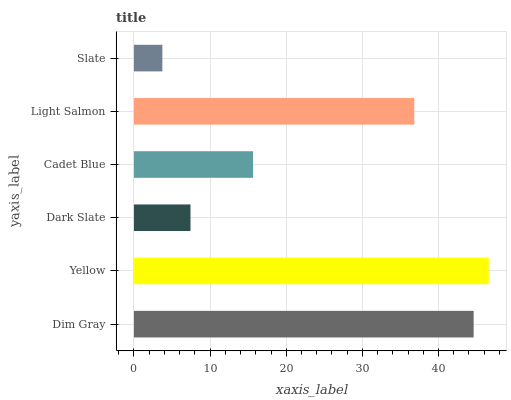Is Slate the minimum?
Answer yes or no. Yes. Is Yellow the maximum?
Answer yes or no. Yes. Is Dark Slate the minimum?
Answer yes or no. No. Is Dark Slate the maximum?
Answer yes or no. No. Is Yellow greater than Dark Slate?
Answer yes or no. Yes. Is Dark Slate less than Yellow?
Answer yes or no. Yes. Is Dark Slate greater than Yellow?
Answer yes or no. No. Is Yellow less than Dark Slate?
Answer yes or no. No. Is Light Salmon the high median?
Answer yes or no. Yes. Is Cadet Blue the low median?
Answer yes or no. Yes. Is Slate the high median?
Answer yes or no. No. Is Slate the low median?
Answer yes or no. No. 